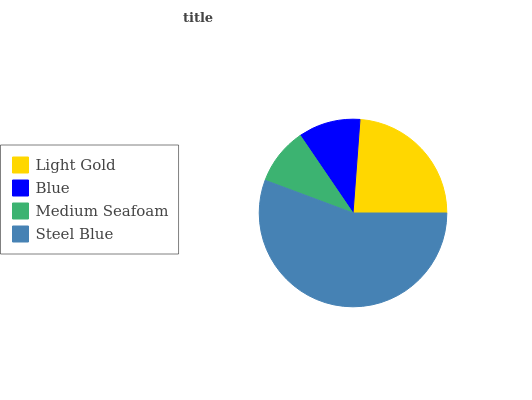Is Medium Seafoam the minimum?
Answer yes or no. Yes. Is Steel Blue the maximum?
Answer yes or no. Yes. Is Blue the minimum?
Answer yes or no. No. Is Blue the maximum?
Answer yes or no. No. Is Light Gold greater than Blue?
Answer yes or no. Yes. Is Blue less than Light Gold?
Answer yes or no. Yes. Is Blue greater than Light Gold?
Answer yes or no. No. Is Light Gold less than Blue?
Answer yes or no. No. Is Light Gold the high median?
Answer yes or no. Yes. Is Blue the low median?
Answer yes or no. Yes. Is Medium Seafoam the high median?
Answer yes or no. No. Is Medium Seafoam the low median?
Answer yes or no. No. 